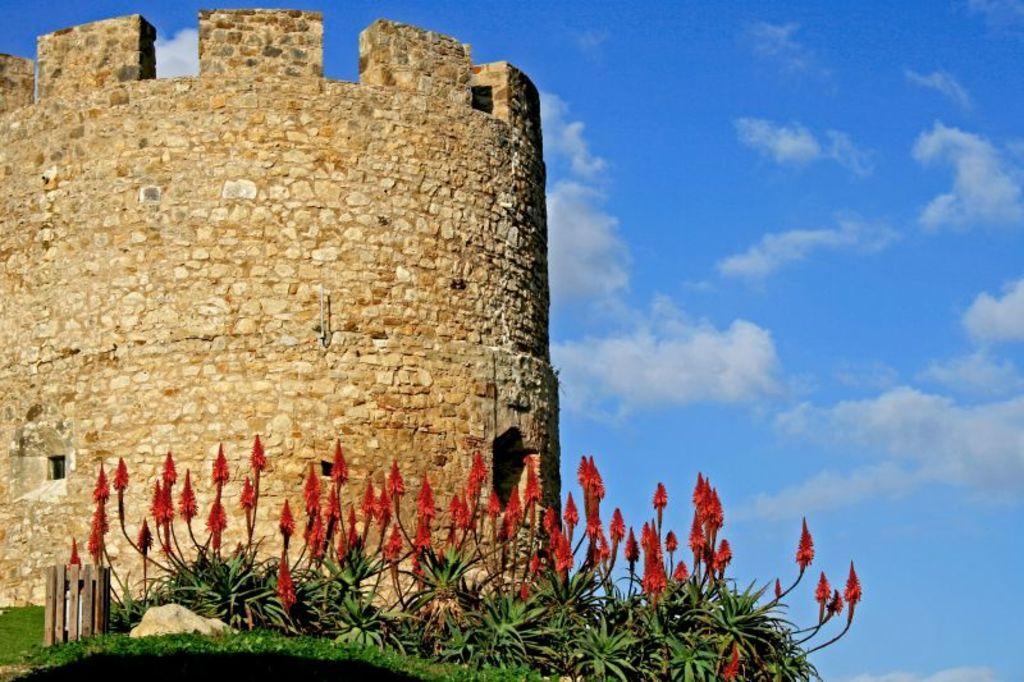In one or two sentences, can you explain what this image depicts? In this picture we can see some plants, flowers and grass in the front, on the left side there is a stone wall, we can see the sky at the top of the picture. 